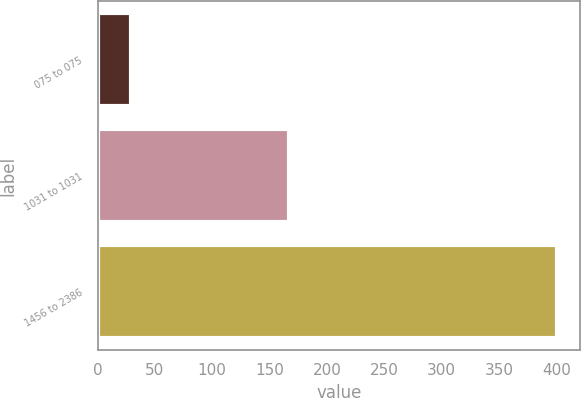Convert chart. <chart><loc_0><loc_0><loc_500><loc_500><bar_chart><fcel>075 to 075<fcel>1031 to 1031<fcel>1456 to 2386<nl><fcel>29<fcel>167<fcel>401<nl></chart> 